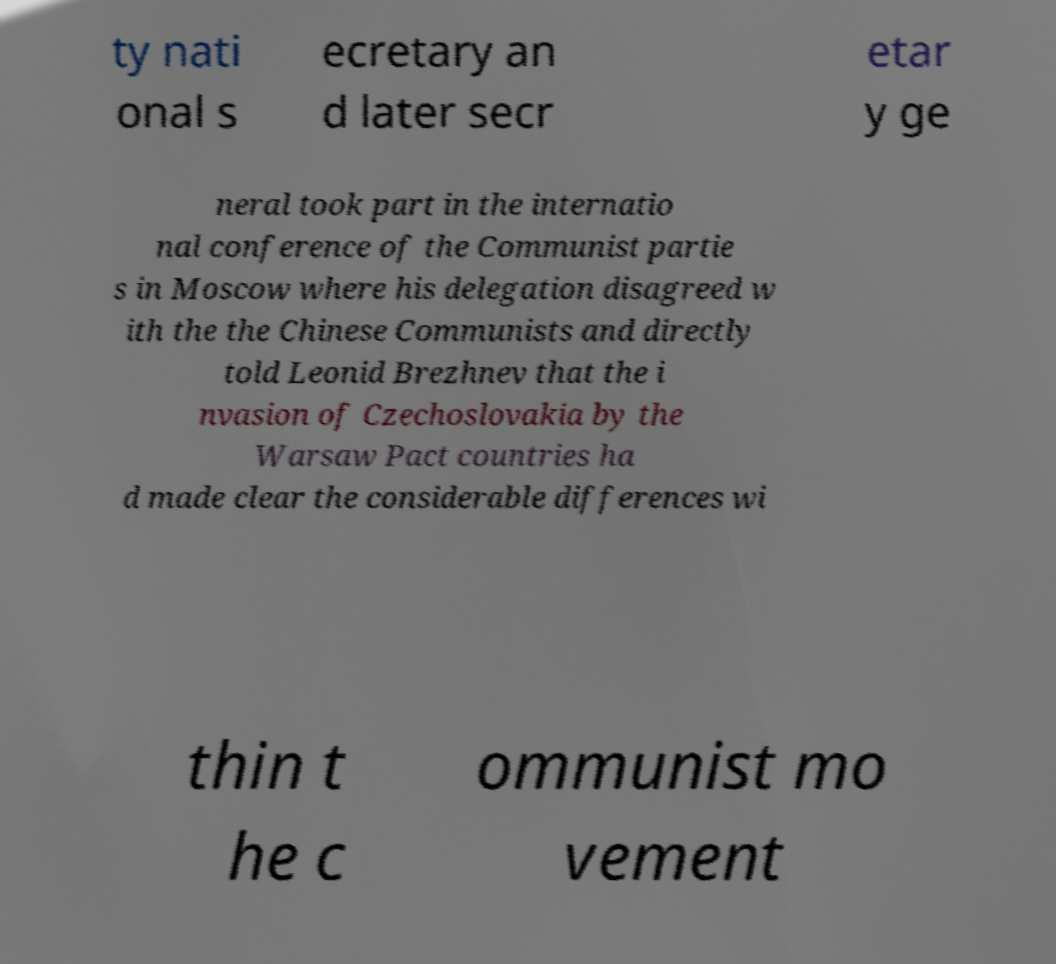Could you assist in decoding the text presented in this image and type it out clearly? ty nati onal s ecretary an d later secr etar y ge neral took part in the internatio nal conference of the Communist partie s in Moscow where his delegation disagreed w ith the the Chinese Communists and directly told Leonid Brezhnev that the i nvasion of Czechoslovakia by the Warsaw Pact countries ha d made clear the considerable differences wi thin t he c ommunist mo vement 